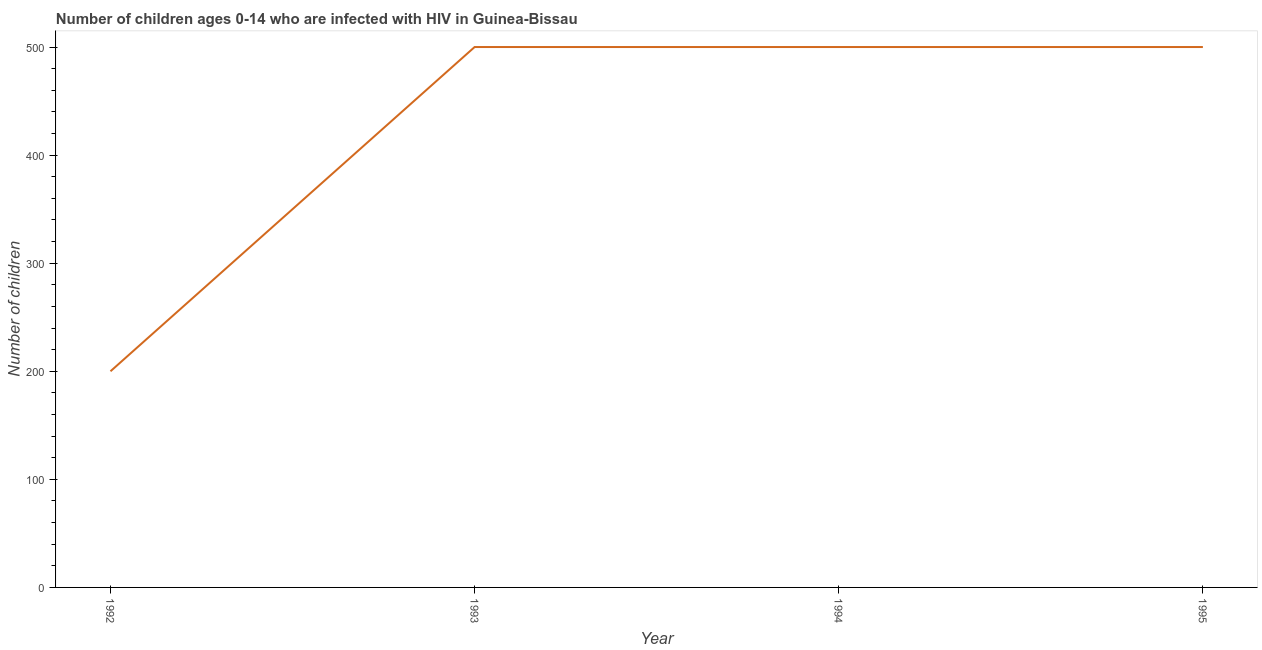What is the number of children living with hiv in 1995?
Your answer should be very brief. 500. Across all years, what is the maximum number of children living with hiv?
Offer a very short reply. 500. Across all years, what is the minimum number of children living with hiv?
Provide a succinct answer. 200. In which year was the number of children living with hiv maximum?
Keep it short and to the point. 1993. In which year was the number of children living with hiv minimum?
Provide a succinct answer. 1992. What is the sum of the number of children living with hiv?
Your response must be concise. 1700. What is the difference between the number of children living with hiv in 1993 and 1994?
Your answer should be very brief. 0. What is the average number of children living with hiv per year?
Provide a short and direct response. 425. In how many years, is the number of children living with hiv greater than 140 ?
Provide a short and direct response. 4. Is the difference between the number of children living with hiv in 1993 and 1994 greater than the difference between any two years?
Your answer should be very brief. No. What is the difference between the highest and the second highest number of children living with hiv?
Your response must be concise. 0. Is the sum of the number of children living with hiv in 1992 and 1994 greater than the maximum number of children living with hiv across all years?
Your response must be concise. Yes. What is the difference between the highest and the lowest number of children living with hiv?
Provide a short and direct response. 300. How many lines are there?
Provide a short and direct response. 1. How many years are there in the graph?
Keep it short and to the point. 4. Are the values on the major ticks of Y-axis written in scientific E-notation?
Ensure brevity in your answer.  No. What is the title of the graph?
Your response must be concise. Number of children ages 0-14 who are infected with HIV in Guinea-Bissau. What is the label or title of the Y-axis?
Ensure brevity in your answer.  Number of children. What is the Number of children of 1992?
Your answer should be very brief. 200. What is the Number of children in 1994?
Offer a terse response. 500. What is the Number of children in 1995?
Offer a very short reply. 500. What is the difference between the Number of children in 1992 and 1993?
Your response must be concise. -300. What is the difference between the Number of children in 1992 and 1994?
Make the answer very short. -300. What is the difference between the Number of children in 1992 and 1995?
Your answer should be compact. -300. What is the difference between the Number of children in 1993 and 1994?
Give a very brief answer. 0. What is the difference between the Number of children in 1993 and 1995?
Your answer should be compact. 0. What is the ratio of the Number of children in 1992 to that in 1995?
Offer a terse response. 0.4. What is the ratio of the Number of children in 1993 to that in 1994?
Your response must be concise. 1. What is the ratio of the Number of children in 1994 to that in 1995?
Provide a succinct answer. 1. 